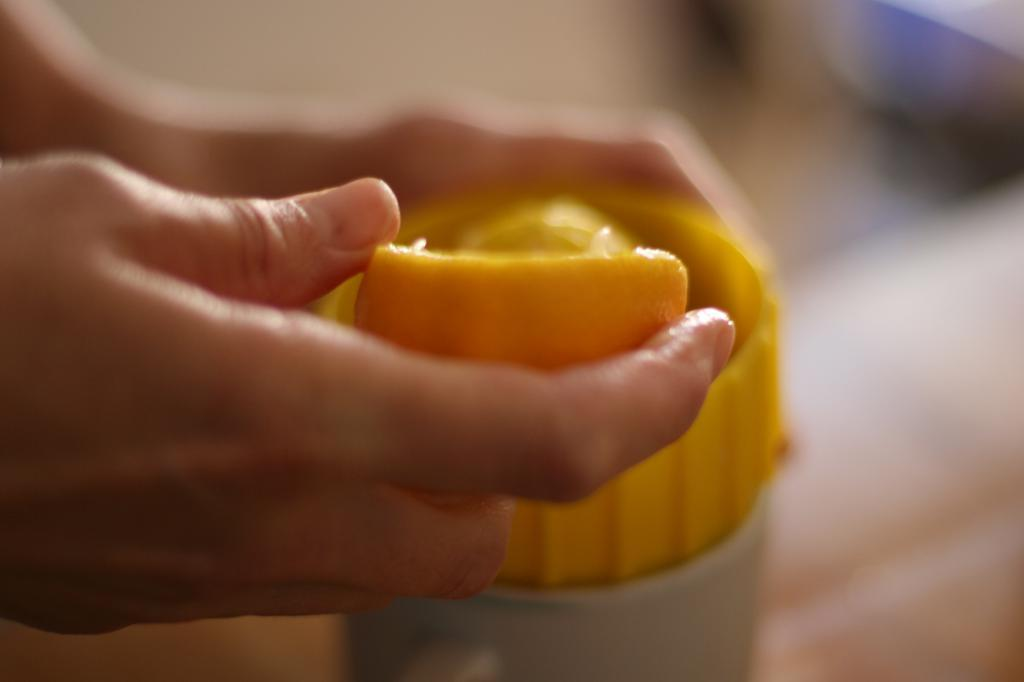What is the main subject of the image? There is a person in the image. What is the person holding in one hand? The person is holding an orange in one hand. What is the person holding in the other hand? The person is holding a juicer in the other hand. Can you describe the background of the image? The background of the image is blurred. What historical event is the person commemorating in the image? The image does not depict any historical event or commemoration; it only shows a person holding an orange and a juicer with a blurred background. 